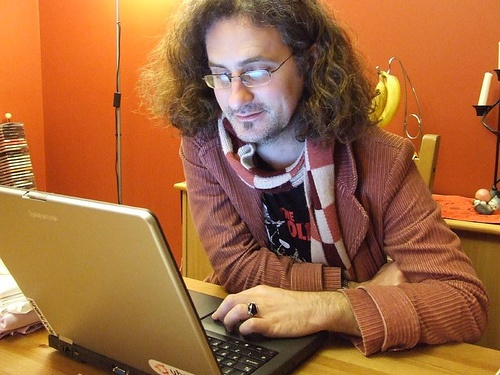Describe the objects in this image and their specific colors. I can see people in orange, maroon, brown, and black tones, laptop in orange, olive, tan, and black tones, banana in orange, khaki, red, and olive tones, chair in orange, maroon, and olive tones, and banana in orange, olive, and khaki tones in this image. 